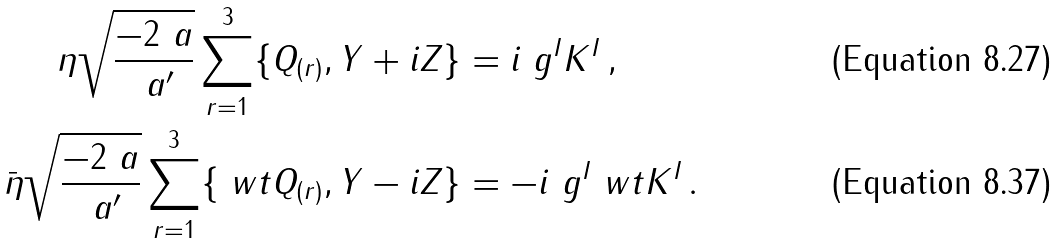<formula> <loc_0><loc_0><loc_500><loc_500>\eta \sqrt { \frac { - 2 \ a } { \ a ^ { \prime } } } \sum _ { r = 1 } ^ { 3 } \{ Q _ { ( r ) } , Y + i Z \} & = i \ g ^ { I } K ^ { I } \, , \\ \bar { \eta } \sqrt { \frac { - 2 \ a } { \ a ^ { \prime } } } \sum _ { r = 1 } ^ { 3 } \{ \ w t { Q } _ { ( r ) } , Y - i Z \} & = - i \ g ^ { I } \ w t { K } ^ { I } \, .</formula> 